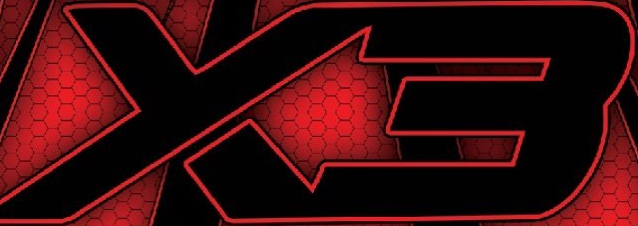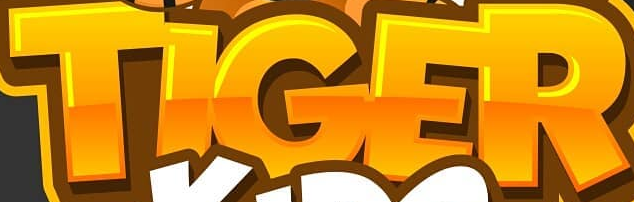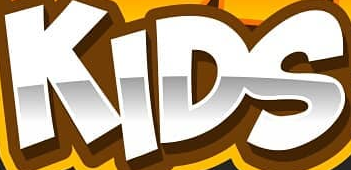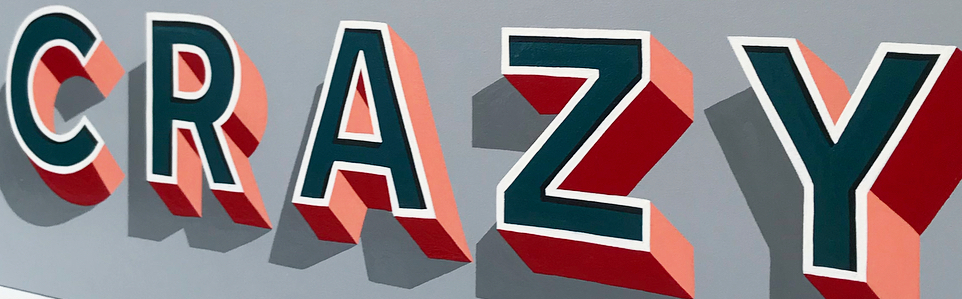Transcribe the words shown in these images in order, separated by a semicolon. X3; TIGER; KIDS; CRAZY 